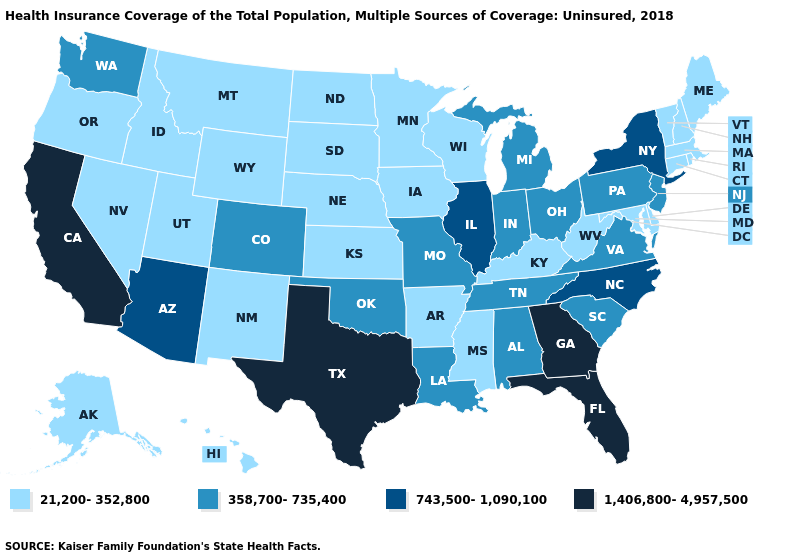Among the states that border Utah , does Wyoming have the highest value?
Answer briefly. No. How many symbols are there in the legend?
Give a very brief answer. 4. Among the states that border Tennessee , does Mississippi have the lowest value?
Give a very brief answer. Yes. How many symbols are there in the legend?
Be succinct. 4. What is the lowest value in the USA?
Answer briefly. 21,200-352,800. Name the states that have a value in the range 743,500-1,090,100?
Give a very brief answer. Arizona, Illinois, New York, North Carolina. Does Florida have a higher value than Georgia?
Answer briefly. No. What is the highest value in the West ?
Be succinct. 1,406,800-4,957,500. Name the states that have a value in the range 1,406,800-4,957,500?
Quick response, please. California, Florida, Georgia, Texas. Name the states that have a value in the range 358,700-735,400?
Answer briefly. Alabama, Colorado, Indiana, Louisiana, Michigan, Missouri, New Jersey, Ohio, Oklahoma, Pennsylvania, South Carolina, Tennessee, Virginia, Washington. What is the value of New Mexico?
Quick response, please. 21,200-352,800. Among the states that border Oklahoma , does Texas have the lowest value?
Keep it brief. No. What is the lowest value in states that border Maryland?
Concise answer only. 21,200-352,800. Name the states that have a value in the range 743,500-1,090,100?
Quick response, please. Arizona, Illinois, New York, North Carolina. Does the map have missing data?
Be succinct. No. 